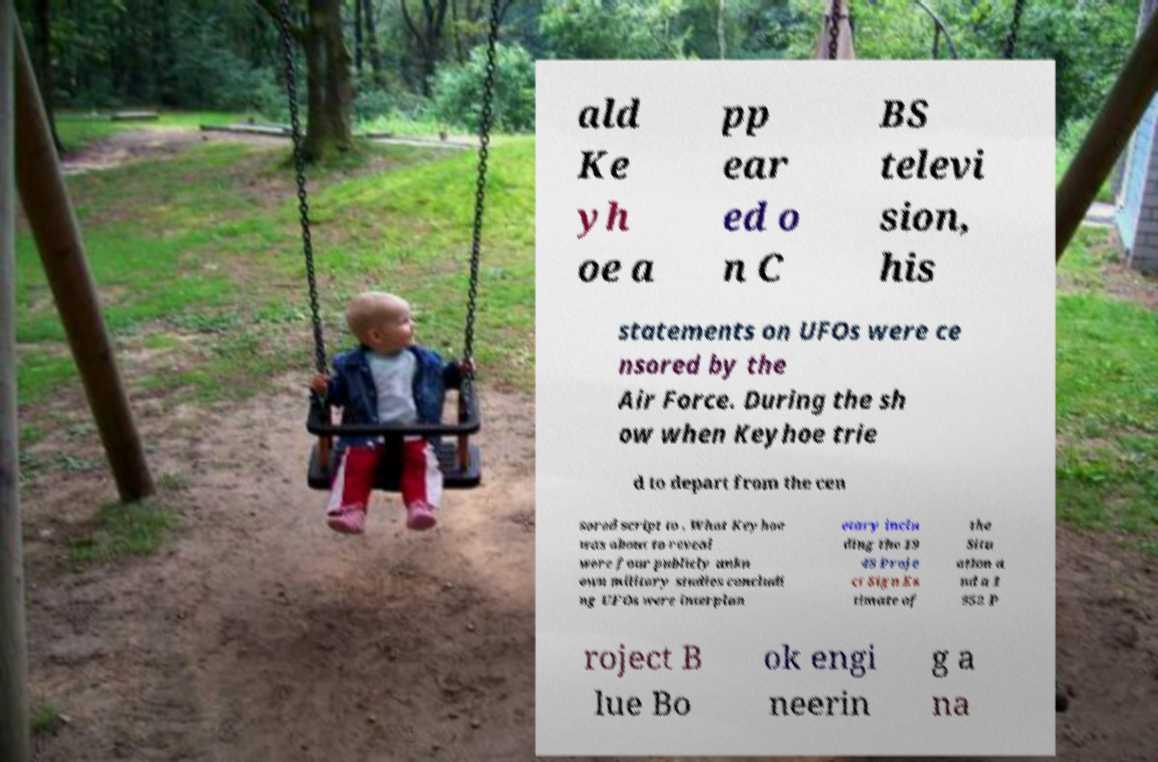Could you assist in decoding the text presented in this image and type it out clearly? ald Ke yh oe a pp ear ed o n C BS televi sion, his statements on UFOs were ce nsored by the Air Force. During the sh ow when Keyhoe trie d to depart from the cen sored script to . What Keyhoe was about to reveal were four publicly unkn own military studies concludi ng UFOs were interplan etary inclu ding the 19 48 Proje ct Sign Es timate of the Situ ation a nd a 1 952 P roject B lue Bo ok engi neerin g a na 